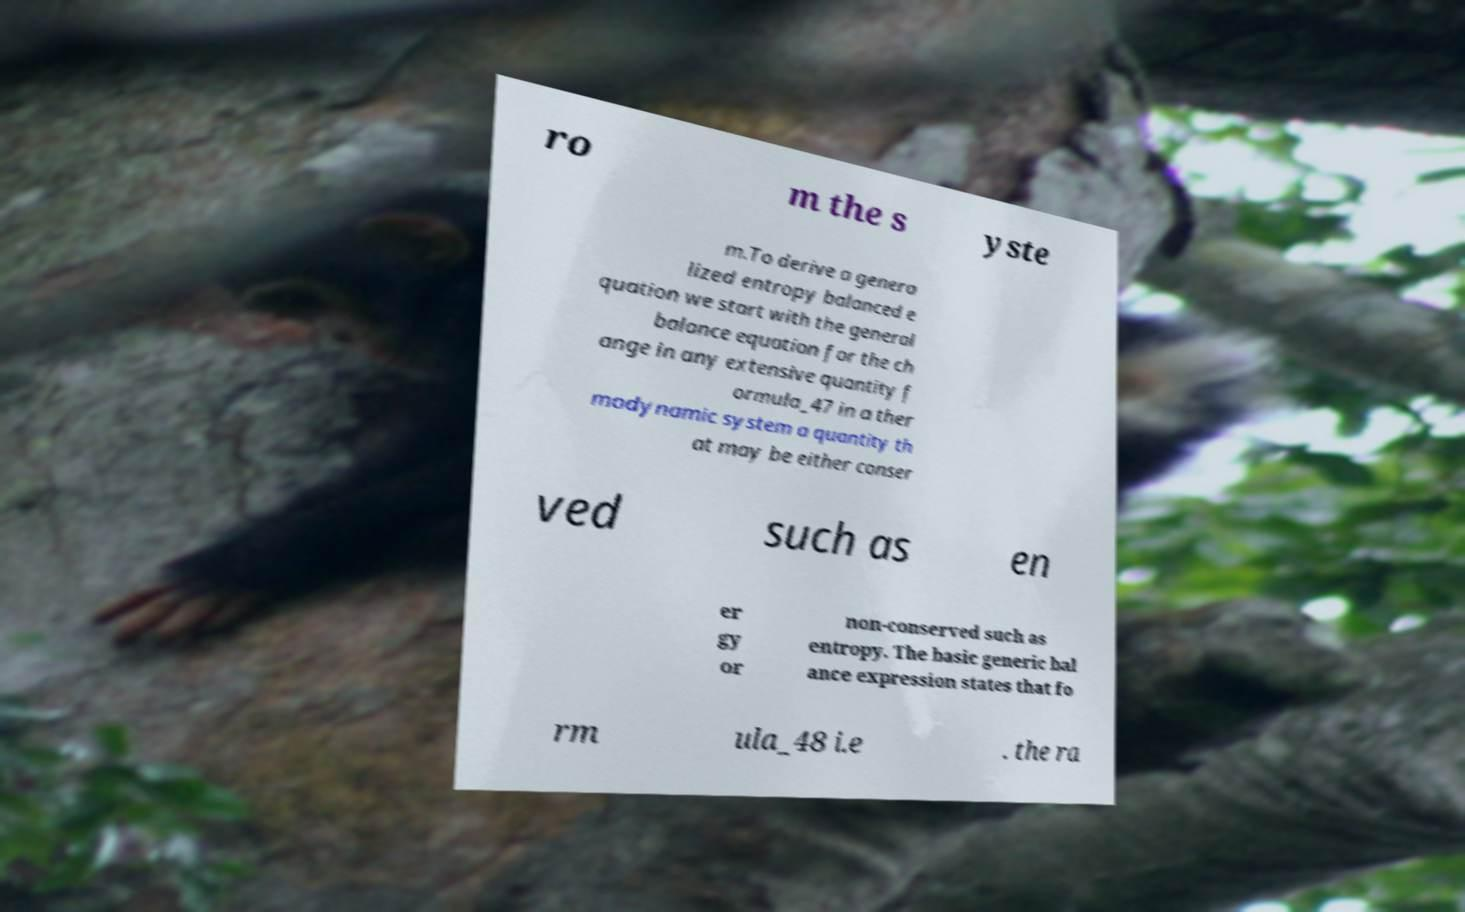I need the written content from this picture converted into text. Can you do that? ro m the s yste m.To derive a genera lized entropy balanced e quation we start with the general balance equation for the ch ange in any extensive quantity f ormula_47 in a ther modynamic system a quantity th at may be either conser ved such as en er gy or non-conserved such as entropy. The basic generic bal ance expression states that fo rm ula_48 i.e . the ra 